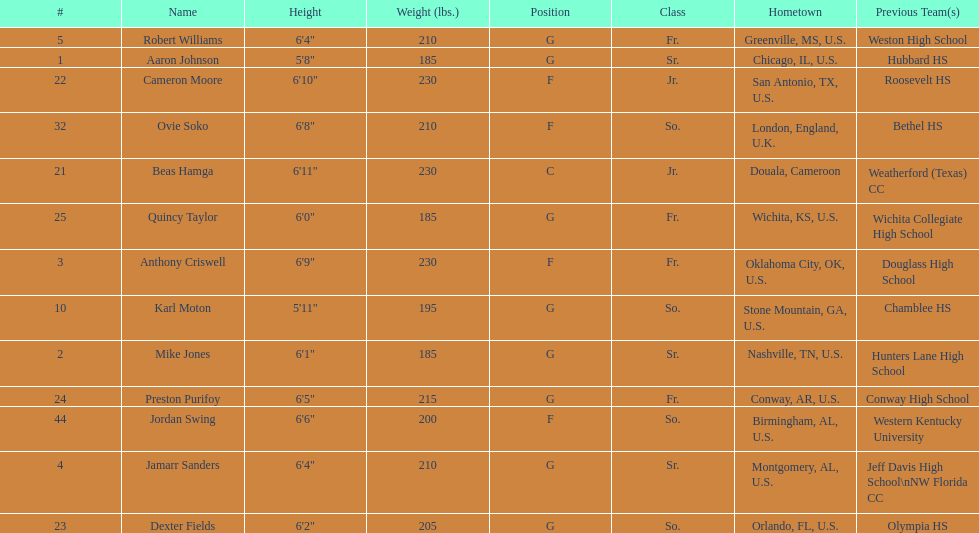What is the number of seniors on the team? 3. 